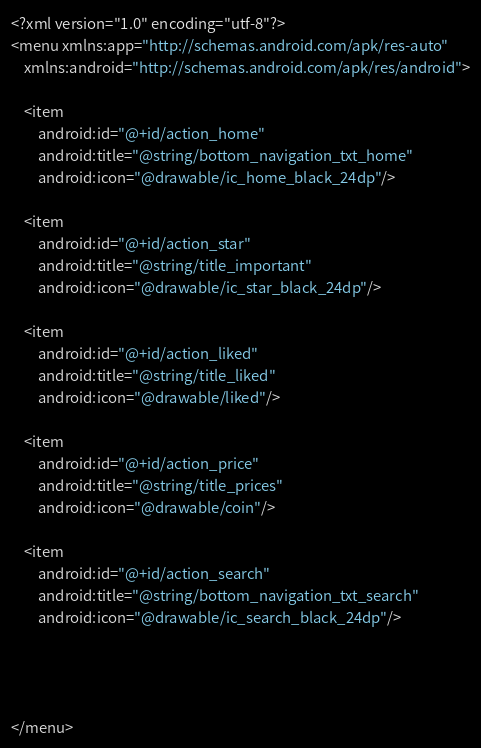<code> <loc_0><loc_0><loc_500><loc_500><_XML_><?xml version="1.0" encoding="utf-8"?>
<menu xmlns:app="http://schemas.android.com/apk/res-auto"
    xmlns:android="http://schemas.android.com/apk/res/android">

    <item
        android:id="@+id/action_home"
        android:title="@string/bottom_navigation_txt_home"
        android:icon="@drawable/ic_home_black_24dp"/>

    <item
        android:id="@+id/action_star"
        android:title="@string/title_important"
        android:icon="@drawable/ic_star_black_24dp"/>

    <item
        android:id="@+id/action_liked"
        android:title="@string/title_liked"
        android:icon="@drawable/liked"/>

    <item
        android:id="@+id/action_price"
        android:title="@string/title_prices"
        android:icon="@drawable/coin"/>

    <item
        android:id="@+id/action_search"
        android:title="@string/bottom_navigation_txt_search"
        android:icon="@drawable/ic_search_black_24dp"/>




</menu></code> 